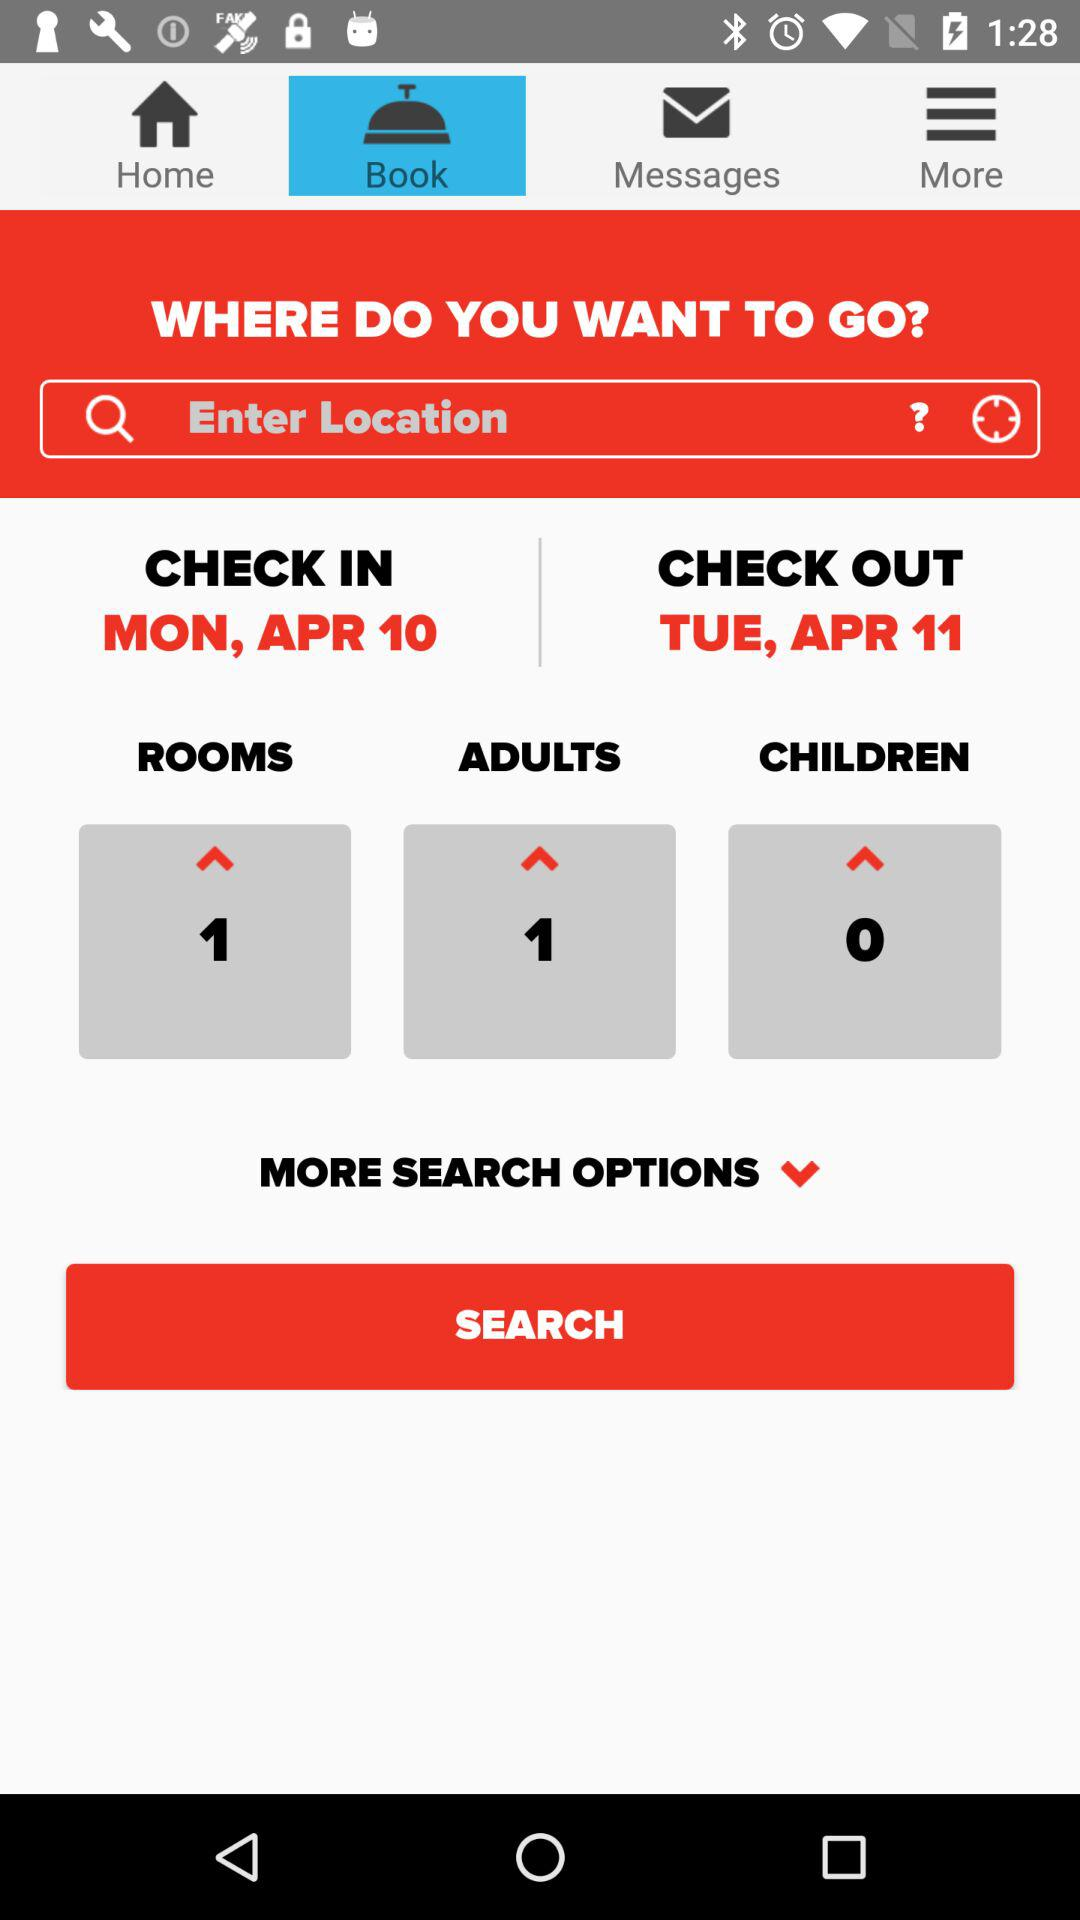What is the selected tab? The selected tab is "Book". 